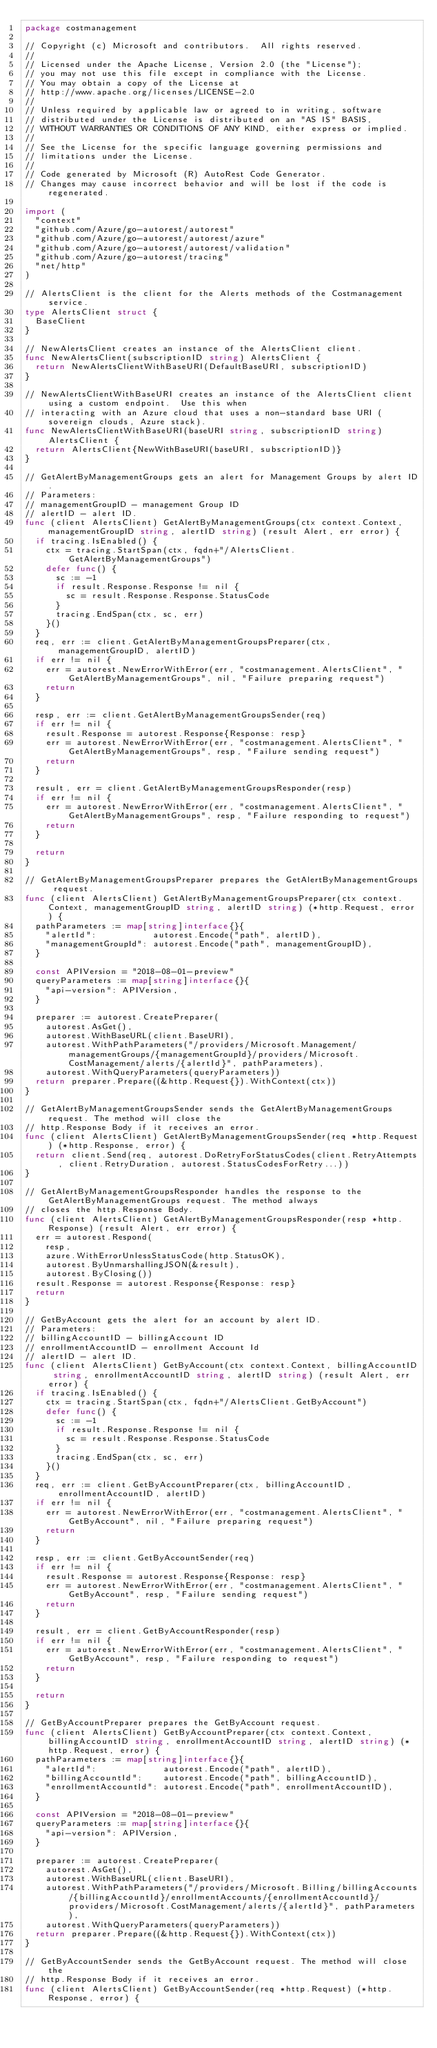<code> <loc_0><loc_0><loc_500><loc_500><_Go_>package costmanagement

// Copyright (c) Microsoft and contributors.  All rights reserved.
//
// Licensed under the Apache License, Version 2.0 (the "License");
// you may not use this file except in compliance with the License.
// You may obtain a copy of the License at
// http://www.apache.org/licenses/LICENSE-2.0
//
// Unless required by applicable law or agreed to in writing, software
// distributed under the License is distributed on an "AS IS" BASIS,
// WITHOUT WARRANTIES OR CONDITIONS OF ANY KIND, either express or implied.
//
// See the License for the specific language governing permissions and
// limitations under the License.
//
// Code generated by Microsoft (R) AutoRest Code Generator.
// Changes may cause incorrect behavior and will be lost if the code is regenerated.

import (
	"context"
	"github.com/Azure/go-autorest/autorest"
	"github.com/Azure/go-autorest/autorest/azure"
	"github.com/Azure/go-autorest/autorest/validation"
	"github.com/Azure/go-autorest/tracing"
	"net/http"
)

// AlertsClient is the client for the Alerts methods of the Costmanagement service.
type AlertsClient struct {
	BaseClient
}

// NewAlertsClient creates an instance of the AlertsClient client.
func NewAlertsClient(subscriptionID string) AlertsClient {
	return NewAlertsClientWithBaseURI(DefaultBaseURI, subscriptionID)
}

// NewAlertsClientWithBaseURI creates an instance of the AlertsClient client using a custom endpoint.  Use this when
// interacting with an Azure cloud that uses a non-standard base URI (sovereign clouds, Azure stack).
func NewAlertsClientWithBaseURI(baseURI string, subscriptionID string) AlertsClient {
	return AlertsClient{NewWithBaseURI(baseURI, subscriptionID)}
}

// GetAlertByManagementGroups gets an alert for Management Groups by alert ID.
// Parameters:
// managementGroupID - management Group ID
// alertID - alert ID.
func (client AlertsClient) GetAlertByManagementGroups(ctx context.Context, managementGroupID string, alertID string) (result Alert, err error) {
	if tracing.IsEnabled() {
		ctx = tracing.StartSpan(ctx, fqdn+"/AlertsClient.GetAlertByManagementGroups")
		defer func() {
			sc := -1
			if result.Response.Response != nil {
				sc = result.Response.Response.StatusCode
			}
			tracing.EndSpan(ctx, sc, err)
		}()
	}
	req, err := client.GetAlertByManagementGroupsPreparer(ctx, managementGroupID, alertID)
	if err != nil {
		err = autorest.NewErrorWithError(err, "costmanagement.AlertsClient", "GetAlertByManagementGroups", nil, "Failure preparing request")
		return
	}

	resp, err := client.GetAlertByManagementGroupsSender(req)
	if err != nil {
		result.Response = autorest.Response{Response: resp}
		err = autorest.NewErrorWithError(err, "costmanagement.AlertsClient", "GetAlertByManagementGroups", resp, "Failure sending request")
		return
	}

	result, err = client.GetAlertByManagementGroupsResponder(resp)
	if err != nil {
		err = autorest.NewErrorWithError(err, "costmanagement.AlertsClient", "GetAlertByManagementGroups", resp, "Failure responding to request")
		return
	}

	return
}

// GetAlertByManagementGroupsPreparer prepares the GetAlertByManagementGroups request.
func (client AlertsClient) GetAlertByManagementGroupsPreparer(ctx context.Context, managementGroupID string, alertID string) (*http.Request, error) {
	pathParameters := map[string]interface{}{
		"alertId":           autorest.Encode("path", alertID),
		"managementGroupId": autorest.Encode("path", managementGroupID),
	}

	const APIVersion = "2018-08-01-preview"
	queryParameters := map[string]interface{}{
		"api-version": APIVersion,
	}

	preparer := autorest.CreatePreparer(
		autorest.AsGet(),
		autorest.WithBaseURL(client.BaseURI),
		autorest.WithPathParameters("/providers/Microsoft.Management/managementGroups/{managementGroupId}/providers/Microsoft.CostManagement/alerts/{alertId}", pathParameters),
		autorest.WithQueryParameters(queryParameters))
	return preparer.Prepare((&http.Request{}).WithContext(ctx))
}

// GetAlertByManagementGroupsSender sends the GetAlertByManagementGroups request. The method will close the
// http.Response Body if it receives an error.
func (client AlertsClient) GetAlertByManagementGroupsSender(req *http.Request) (*http.Response, error) {
	return client.Send(req, autorest.DoRetryForStatusCodes(client.RetryAttempts, client.RetryDuration, autorest.StatusCodesForRetry...))
}

// GetAlertByManagementGroupsResponder handles the response to the GetAlertByManagementGroups request. The method always
// closes the http.Response Body.
func (client AlertsClient) GetAlertByManagementGroupsResponder(resp *http.Response) (result Alert, err error) {
	err = autorest.Respond(
		resp,
		azure.WithErrorUnlessStatusCode(http.StatusOK),
		autorest.ByUnmarshallingJSON(&result),
		autorest.ByClosing())
	result.Response = autorest.Response{Response: resp}
	return
}

// GetByAccount gets the alert for an account by alert ID.
// Parameters:
// billingAccountID - billingAccount ID
// enrollmentAccountID - enrollment Account Id
// alertID - alert ID.
func (client AlertsClient) GetByAccount(ctx context.Context, billingAccountID string, enrollmentAccountID string, alertID string) (result Alert, err error) {
	if tracing.IsEnabled() {
		ctx = tracing.StartSpan(ctx, fqdn+"/AlertsClient.GetByAccount")
		defer func() {
			sc := -1
			if result.Response.Response != nil {
				sc = result.Response.Response.StatusCode
			}
			tracing.EndSpan(ctx, sc, err)
		}()
	}
	req, err := client.GetByAccountPreparer(ctx, billingAccountID, enrollmentAccountID, alertID)
	if err != nil {
		err = autorest.NewErrorWithError(err, "costmanagement.AlertsClient", "GetByAccount", nil, "Failure preparing request")
		return
	}

	resp, err := client.GetByAccountSender(req)
	if err != nil {
		result.Response = autorest.Response{Response: resp}
		err = autorest.NewErrorWithError(err, "costmanagement.AlertsClient", "GetByAccount", resp, "Failure sending request")
		return
	}

	result, err = client.GetByAccountResponder(resp)
	if err != nil {
		err = autorest.NewErrorWithError(err, "costmanagement.AlertsClient", "GetByAccount", resp, "Failure responding to request")
		return
	}

	return
}

// GetByAccountPreparer prepares the GetByAccount request.
func (client AlertsClient) GetByAccountPreparer(ctx context.Context, billingAccountID string, enrollmentAccountID string, alertID string) (*http.Request, error) {
	pathParameters := map[string]interface{}{
		"alertId":             autorest.Encode("path", alertID),
		"billingAccountId":    autorest.Encode("path", billingAccountID),
		"enrollmentAccountId": autorest.Encode("path", enrollmentAccountID),
	}

	const APIVersion = "2018-08-01-preview"
	queryParameters := map[string]interface{}{
		"api-version": APIVersion,
	}

	preparer := autorest.CreatePreparer(
		autorest.AsGet(),
		autorest.WithBaseURL(client.BaseURI),
		autorest.WithPathParameters("/providers/Microsoft.Billing/billingAccounts/{billingAccountId}/enrollmentAccounts/{enrollmentAccountId}/providers/Microsoft.CostManagement/alerts/{alertId}", pathParameters),
		autorest.WithQueryParameters(queryParameters))
	return preparer.Prepare((&http.Request{}).WithContext(ctx))
}

// GetByAccountSender sends the GetByAccount request. The method will close the
// http.Response Body if it receives an error.
func (client AlertsClient) GetByAccountSender(req *http.Request) (*http.Response, error) {</code> 